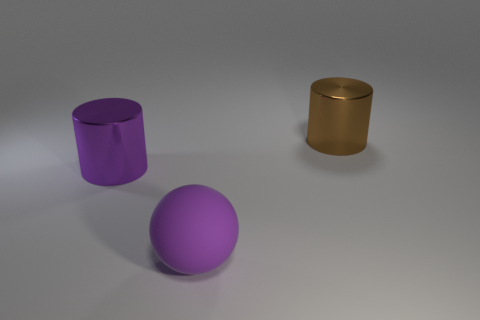There is a cylinder that is the same color as the matte thing; what material is it?
Ensure brevity in your answer.  Metal. What is the shape of the large purple object behind the matte ball?
Your answer should be compact. Cylinder. Is the number of purple spheres to the left of the purple matte ball less than the number of purple metal objects that are to the left of the large brown cylinder?
Make the answer very short. Yes. Is the cylinder behind the big purple cylinder made of the same material as the big cylinder to the left of the big brown cylinder?
Provide a short and direct response. Yes. There is a rubber thing; what shape is it?
Your answer should be compact. Sphere. Are there more cylinders behind the purple cylinder than big brown things in front of the big purple ball?
Provide a short and direct response. Yes. There is a purple object that is on the left side of the big rubber sphere; does it have the same shape as the large metallic thing right of the purple matte ball?
Provide a short and direct response. Yes. What number of other things are there of the same size as the brown metallic cylinder?
Provide a short and direct response. 2. Does the cylinder that is to the left of the purple rubber ball have the same material as the big purple ball?
Keep it short and to the point. No. The other big shiny thing that is the same shape as the purple metallic object is what color?
Your answer should be very brief. Brown. 